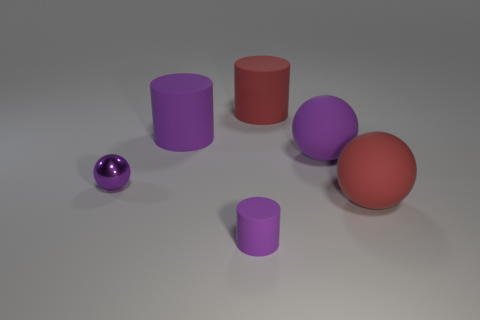What is the color of the object that is both on the left side of the tiny purple rubber cylinder and behind the small metallic sphere?
Offer a very short reply. Purple. How many cylinders are purple things or red matte objects?
Make the answer very short. 3. Are there fewer purple shiny spheres in front of the tiny purple cylinder than tiny brown spheres?
Your response must be concise. No. There is a small thing that is made of the same material as the big purple sphere; what is its shape?
Provide a succinct answer. Cylinder. How many tiny metal things have the same color as the small cylinder?
Ensure brevity in your answer.  1. How many things are either large objects or small purple metallic balls?
Your response must be concise. 5. What is the small purple thing that is left of the purple cylinder in front of the red sphere made of?
Provide a succinct answer. Metal. Is there a large cylinder that has the same material as the small cylinder?
Offer a very short reply. Yes. There is a purple matte thing right of the rubber object in front of the large ball in front of the purple metallic sphere; what is its shape?
Provide a short and direct response. Sphere. What material is the small sphere?
Offer a very short reply. Metal. 